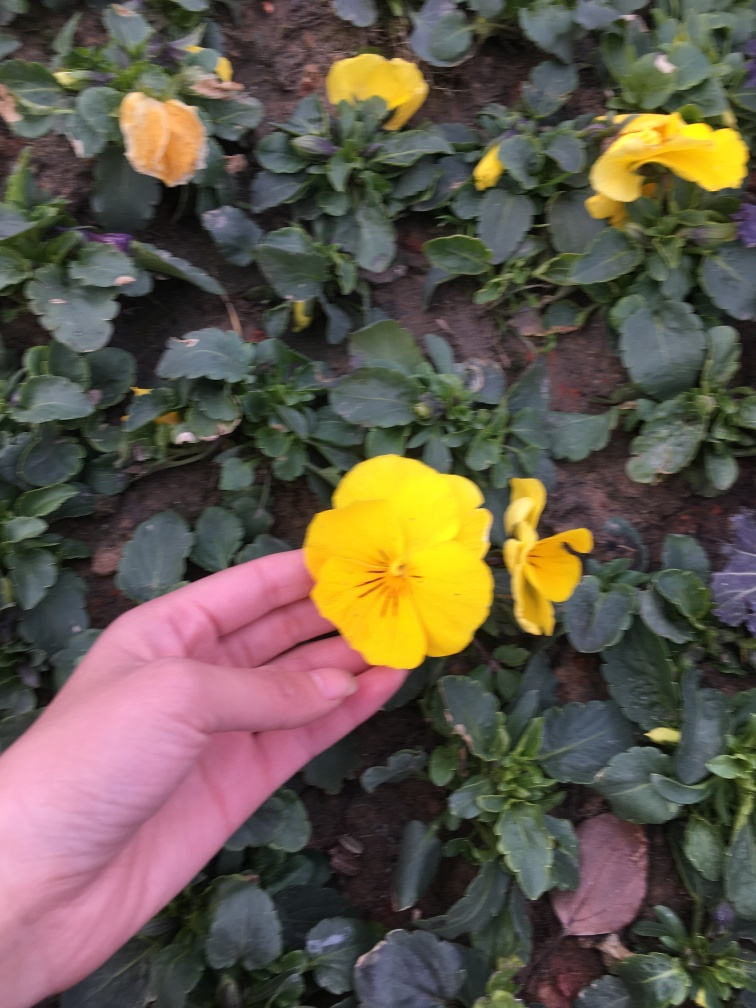Can you describe the flower in the image more precisely? The image shows a vivid yellow pansy flower held between someone's thumb and forefinger. This particular pansy has large petals characterized by a deep yellow hue with dark lines radiating from its center, which is typical of the pansy's 'face' pattern. What can you tell me about the pansy's habitat preferences? Pansies thrive in cool to moderate climates and prefer moist, humus-rich, well-draining soil. They often adorn garden beds and containers and are suitable for a variety of landscaping designs due to their vibrant colors and patterns. 